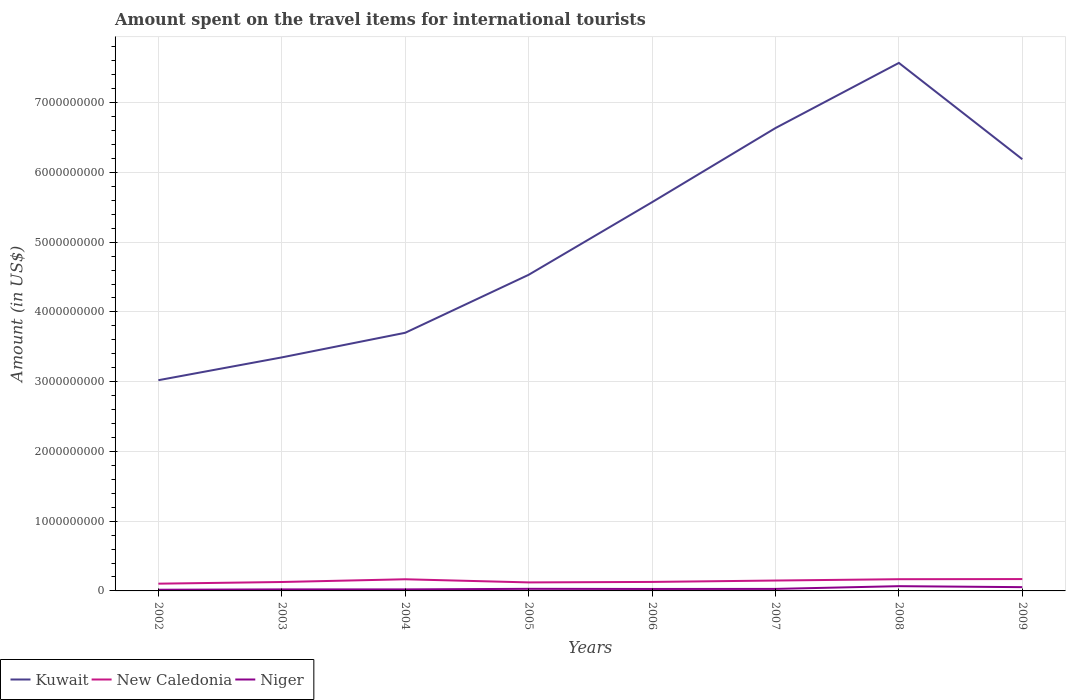How many different coloured lines are there?
Give a very brief answer. 3. Does the line corresponding to New Caledonia intersect with the line corresponding to Kuwait?
Keep it short and to the point. No. Across all years, what is the maximum amount spent on the travel items for international tourists in Niger?
Offer a terse response. 1.70e+07. What is the total amount spent on the travel items for international tourists in Kuwait in the graph?
Offer a terse response. -9.34e+08. What is the difference between the highest and the second highest amount spent on the travel items for international tourists in Niger?
Your answer should be compact. 5.10e+07. What is the difference between the highest and the lowest amount spent on the travel items for international tourists in New Caledonia?
Provide a succinct answer. 4. How many lines are there?
Provide a short and direct response. 3. Are the values on the major ticks of Y-axis written in scientific E-notation?
Provide a succinct answer. No. Does the graph contain grids?
Make the answer very short. Yes. How are the legend labels stacked?
Keep it short and to the point. Horizontal. What is the title of the graph?
Offer a terse response. Amount spent on the travel items for international tourists. Does "United Kingdom" appear as one of the legend labels in the graph?
Your response must be concise. No. What is the label or title of the Y-axis?
Ensure brevity in your answer.  Amount (in US$). What is the Amount (in US$) in Kuwait in 2002?
Offer a terse response. 3.02e+09. What is the Amount (in US$) of New Caledonia in 2002?
Offer a very short reply. 1.04e+08. What is the Amount (in US$) of Niger in 2002?
Offer a very short reply. 1.70e+07. What is the Amount (in US$) in Kuwait in 2003?
Make the answer very short. 3.35e+09. What is the Amount (in US$) of New Caledonia in 2003?
Provide a succinct answer. 1.28e+08. What is the Amount (in US$) of Niger in 2003?
Offer a very short reply. 2.20e+07. What is the Amount (in US$) in Kuwait in 2004?
Provide a succinct answer. 3.70e+09. What is the Amount (in US$) in New Caledonia in 2004?
Offer a terse response. 1.67e+08. What is the Amount (in US$) of Niger in 2004?
Make the answer very short. 2.20e+07. What is the Amount (in US$) in Kuwait in 2005?
Provide a short and direct response. 4.53e+09. What is the Amount (in US$) of New Caledonia in 2005?
Provide a succinct answer. 1.22e+08. What is the Amount (in US$) of Niger in 2005?
Offer a terse response. 3.00e+07. What is the Amount (in US$) in Kuwait in 2006?
Your answer should be compact. 5.57e+09. What is the Amount (in US$) of New Caledonia in 2006?
Provide a short and direct response. 1.29e+08. What is the Amount (in US$) in Niger in 2006?
Your answer should be very brief. 2.80e+07. What is the Amount (in US$) of Kuwait in 2007?
Your answer should be compact. 6.64e+09. What is the Amount (in US$) of New Caledonia in 2007?
Give a very brief answer. 1.49e+08. What is the Amount (in US$) in Niger in 2007?
Make the answer very short. 2.90e+07. What is the Amount (in US$) in Kuwait in 2008?
Make the answer very short. 7.57e+09. What is the Amount (in US$) in New Caledonia in 2008?
Keep it short and to the point. 1.68e+08. What is the Amount (in US$) of Niger in 2008?
Keep it short and to the point. 6.80e+07. What is the Amount (in US$) in Kuwait in 2009?
Your answer should be very brief. 6.19e+09. What is the Amount (in US$) of New Caledonia in 2009?
Your answer should be compact. 1.70e+08. What is the Amount (in US$) in Niger in 2009?
Provide a succinct answer. 5.40e+07. Across all years, what is the maximum Amount (in US$) in Kuwait?
Your answer should be compact. 7.57e+09. Across all years, what is the maximum Amount (in US$) of New Caledonia?
Provide a short and direct response. 1.70e+08. Across all years, what is the maximum Amount (in US$) in Niger?
Ensure brevity in your answer.  6.80e+07. Across all years, what is the minimum Amount (in US$) of Kuwait?
Offer a terse response. 3.02e+09. Across all years, what is the minimum Amount (in US$) in New Caledonia?
Make the answer very short. 1.04e+08. Across all years, what is the minimum Amount (in US$) of Niger?
Keep it short and to the point. 1.70e+07. What is the total Amount (in US$) of Kuwait in the graph?
Offer a very short reply. 4.06e+1. What is the total Amount (in US$) of New Caledonia in the graph?
Ensure brevity in your answer.  1.14e+09. What is the total Amount (in US$) of Niger in the graph?
Offer a very short reply. 2.70e+08. What is the difference between the Amount (in US$) in Kuwait in 2002 and that in 2003?
Your answer should be very brief. -3.27e+08. What is the difference between the Amount (in US$) in New Caledonia in 2002 and that in 2003?
Provide a short and direct response. -2.40e+07. What is the difference between the Amount (in US$) in Niger in 2002 and that in 2003?
Your answer should be very brief. -5.00e+06. What is the difference between the Amount (in US$) of Kuwait in 2002 and that in 2004?
Make the answer very short. -6.80e+08. What is the difference between the Amount (in US$) in New Caledonia in 2002 and that in 2004?
Your answer should be very brief. -6.30e+07. What is the difference between the Amount (in US$) in Niger in 2002 and that in 2004?
Offer a terse response. -5.00e+06. What is the difference between the Amount (in US$) of Kuwait in 2002 and that in 2005?
Provide a short and direct response. -1.51e+09. What is the difference between the Amount (in US$) of New Caledonia in 2002 and that in 2005?
Keep it short and to the point. -1.80e+07. What is the difference between the Amount (in US$) in Niger in 2002 and that in 2005?
Keep it short and to the point. -1.30e+07. What is the difference between the Amount (in US$) in Kuwait in 2002 and that in 2006?
Offer a very short reply. -2.55e+09. What is the difference between the Amount (in US$) in New Caledonia in 2002 and that in 2006?
Keep it short and to the point. -2.50e+07. What is the difference between the Amount (in US$) of Niger in 2002 and that in 2006?
Make the answer very short. -1.10e+07. What is the difference between the Amount (in US$) of Kuwait in 2002 and that in 2007?
Offer a terse response. -3.62e+09. What is the difference between the Amount (in US$) of New Caledonia in 2002 and that in 2007?
Your answer should be very brief. -4.50e+07. What is the difference between the Amount (in US$) in Niger in 2002 and that in 2007?
Make the answer very short. -1.20e+07. What is the difference between the Amount (in US$) of Kuwait in 2002 and that in 2008?
Provide a short and direct response. -4.55e+09. What is the difference between the Amount (in US$) of New Caledonia in 2002 and that in 2008?
Your answer should be compact. -6.40e+07. What is the difference between the Amount (in US$) in Niger in 2002 and that in 2008?
Make the answer very short. -5.10e+07. What is the difference between the Amount (in US$) in Kuwait in 2002 and that in 2009?
Provide a short and direct response. -3.17e+09. What is the difference between the Amount (in US$) of New Caledonia in 2002 and that in 2009?
Your answer should be compact. -6.60e+07. What is the difference between the Amount (in US$) of Niger in 2002 and that in 2009?
Offer a terse response. -3.70e+07. What is the difference between the Amount (in US$) of Kuwait in 2003 and that in 2004?
Your response must be concise. -3.53e+08. What is the difference between the Amount (in US$) in New Caledonia in 2003 and that in 2004?
Your answer should be very brief. -3.90e+07. What is the difference between the Amount (in US$) of Kuwait in 2003 and that in 2005?
Offer a very short reply. -1.18e+09. What is the difference between the Amount (in US$) in New Caledonia in 2003 and that in 2005?
Your answer should be compact. 6.00e+06. What is the difference between the Amount (in US$) in Niger in 2003 and that in 2005?
Your answer should be very brief. -8.00e+06. What is the difference between the Amount (in US$) in Kuwait in 2003 and that in 2006?
Your answer should be very brief. -2.22e+09. What is the difference between the Amount (in US$) of New Caledonia in 2003 and that in 2006?
Make the answer very short. -1.00e+06. What is the difference between the Amount (in US$) of Niger in 2003 and that in 2006?
Offer a terse response. -6.00e+06. What is the difference between the Amount (in US$) of Kuwait in 2003 and that in 2007?
Your answer should be compact. -3.29e+09. What is the difference between the Amount (in US$) in New Caledonia in 2003 and that in 2007?
Your answer should be very brief. -2.10e+07. What is the difference between the Amount (in US$) of Niger in 2003 and that in 2007?
Offer a very short reply. -7.00e+06. What is the difference between the Amount (in US$) in Kuwait in 2003 and that in 2008?
Ensure brevity in your answer.  -4.22e+09. What is the difference between the Amount (in US$) in New Caledonia in 2003 and that in 2008?
Ensure brevity in your answer.  -4.00e+07. What is the difference between the Amount (in US$) of Niger in 2003 and that in 2008?
Keep it short and to the point. -4.60e+07. What is the difference between the Amount (in US$) of Kuwait in 2003 and that in 2009?
Keep it short and to the point. -2.84e+09. What is the difference between the Amount (in US$) of New Caledonia in 2003 and that in 2009?
Ensure brevity in your answer.  -4.20e+07. What is the difference between the Amount (in US$) in Niger in 2003 and that in 2009?
Offer a terse response. -3.20e+07. What is the difference between the Amount (in US$) in Kuwait in 2004 and that in 2005?
Your response must be concise. -8.31e+08. What is the difference between the Amount (in US$) in New Caledonia in 2004 and that in 2005?
Offer a terse response. 4.50e+07. What is the difference between the Amount (in US$) in Niger in 2004 and that in 2005?
Give a very brief answer. -8.00e+06. What is the difference between the Amount (in US$) in Kuwait in 2004 and that in 2006?
Give a very brief answer. -1.87e+09. What is the difference between the Amount (in US$) in New Caledonia in 2004 and that in 2006?
Your response must be concise. 3.80e+07. What is the difference between the Amount (in US$) in Niger in 2004 and that in 2006?
Offer a very short reply. -6.00e+06. What is the difference between the Amount (in US$) in Kuwait in 2004 and that in 2007?
Provide a short and direct response. -2.94e+09. What is the difference between the Amount (in US$) in New Caledonia in 2004 and that in 2007?
Your response must be concise. 1.80e+07. What is the difference between the Amount (in US$) in Niger in 2004 and that in 2007?
Your answer should be very brief. -7.00e+06. What is the difference between the Amount (in US$) in Kuwait in 2004 and that in 2008?
Provide a succinct answer. -3.87e+09. What is the difference between the Amount (in US$) of New Caledonia in 2004 and that in 2008?
Ensure brevity in your answer.  -1.00e+06. What is the difference between the Amount (in US$) of Niger in 2004 and that in 2008?
Your answer should be very brief. -4.60e+07. What is the difference between the Amount (in US$) of Kuwait in 2004 and that in 2009?
Offer a very short reply. -2.49e+09. What is the difference between the Amount (in US$) in Niger in 2004 and that in 2009?
Provide a succinct answer. -3.20e+07. What is the difference between the Amount (in US$) of Kuwait in 2005 and that in 2006?
Keep it short and to the point. -1.04e+09. What is the difference between the Amount (in US$) of New Caledonia in 2005 and that in 2006?
Give a very brief answer. -7.00e+06. What is the difference between the Amount (in US$) of Niger in 2005 and that in 2006?
Keep it short and to the point. 2.00e+06. What is the difference between the Amount (in US$) in Kuwait in 2005 and that in 2007?
Your response must be concise. -2.10e+09. What is the difference between the Amount (in US$) in New Caledonia in 2005 and that in 2007?
Make the answer very short. -2.70e+07. What is the difference between the Amount (in US$) in Niger in 2005 and that in 2007?
Provide a short and direct response. 1.00e+06. What is the difference between the Amount (in US$) in Kuwait in 2005 and that in 2008?
Offer a very short reply. -3.04e+09. What is the difference between the Amount (in US$) of New Caledonia in 2005 and that in 2008?
Offer a terse response. -4.60e+07. What is the difference between the Amount (in US$) of Niger in 2005 and that in 2008?
Make the answer very short. -3.80e+07. What is the difference between the Amount (in US$) of Kuwait in 2005 and that in 2009?
Your answer should be compact. -1.66e+09. What is the difference between the Amount (in US$) in New Caledonia in 2005 and that in 2009?
Give a very brief answer. -4.80e+07. What is the difference between the Amount (in US$) of Niger in 2005 and that in 2009?
Offer a terse response. -2.40e+07. What is the difference between the Amount (in US$) in Kuwait in 2006 and that in 2007?
Offer a terse response. -1.06e+09. What is the difference between the Amount (in US$) of New Caledonia in 2006 and that in 2007?
Your response must be concise. -2.00e+07. What is the difference between the Amount (in US$) of Niger in 2006 and that in 2007?
Make the answer very short. -1.00e+06. What is the difference between the Amount (in US$) in Kuwait in 2006 and that in 2008?
Your response must be concise. -2.00e+09. What is the difference between the Amount (in US$) of New Caledonia in 2006 and that in 2008?
Your response must be concise. -3.90e+07. What is the difference between the Amount (in US$) in Niger in 2006 and that in 2008?
Give a very brief answer. -4.00e+07. What is the difference between the Amount (in US$) in Kuwait in 2006 and that in 2009?
Provide a short and direct response. -6.16e+08. What is the difference between the Amount (in US$) of New Caledonia in 2006 and that in 2009?
Your response must be concise. -4.10e+07. What is the difference between the Amount (in US$) in Niger in 2006 and that in 2009?
Provide a short and direct response. -2.60e+07. What is the difference between the Amount (in US$) of Kuwait in 2007 and that in 2008?
Make the answer very short. -9.34e+08. What is the difference between the Amount (in US$) in New Caledonia in 2007 and that in 2008?
Keep it short and to the point. -1.90e+07. What is the difference between the Amount (in US$) of Niger in 2007 and that in 2008?
Keep it short and to the point. -3.90e+07. What is the difference between the Amount (in US$) in Kuwait in 2007 and that in 2009?
Your answer should be very brief. 4.47e+08. What is the difference between the Amount (in US$) in New Caledonia in 2007 and that in 2009?
Give a very brief answer. -2.10e+07. What is the difference between the Amount (in US$) of Niger in 2007 and that in 2009?
Make the answer very short. -2.50e+07. What is the difference between the Amount (in US$) of Kuwait in 2008 and that in 2009?
Ensure brevity in your answer.  1.38e+09. What is the difference between the Amount (in US$) of New Caledonia in 2008 and that in 2009?
Your answer should be very brief. -2.00e+06. What is the difference between the Amount (in US$) of Niger in 2008 and that in 2009?
Make the answer very short. 1.40e+07. What is the difference between the Amount (in US$) in Kuwait in 2002 and the Amount (in US$) in New Caledonia in 2003?
Offer a very short reply. 2.89e+09. What is the difference between the Amount (in US$) of Kuwait in 2002 and the Amount (in US$) of Niger in 2003?
Your answer should be very brief. 3.00e+09. What is the difference between the Amount (in US$) in New Caledonia in 2002 and the Amount (in US$) in Niger in 2003?
Your answer should be very brief. 8.20e+07. What is the difference between the Amount (in US$) in Kuwait in 2002 and the Amount (in US$) in New Caledonia in 2004?
Provide a succinct answer. 2.85e+09. What is the difference between the Amount (in US$) of Kuwait in 2002 and the Amount (in US$) of Niger in 2004?
Ensure brevity in your answer.  3.00e+09. What is the difference between the Amount (in US$) of New Caledonia in 2002 and the Amount (in US$) of Niger in 2004?
Your answer should be very brief. 8.20e+07. What is the difference between the Amount (in US$) of Kuwait in 2002 and the Amount (in US$) of New Caledonia in 2005?
Provide a succinct answer. 2.90e+09. What is the difference between the Amount (in US$) of Kuwait in 2002 and the Amount (in US$) of Niger in 2005?
Give a very brief answer. 2.99e+09. What is the difference between the Amount (in US$) in New Caledonia in 2002 and the Amount (in US$) in Niger in 2005?
Keep it short and to the point. 7.40e+07. What is the difference between the Amount (in US$) in Kuwait in 2002 and the Amount (in US$) in New Caledonia in 2006?
Give a very brief answer. 2.89e+09. What is the difference between the Amount (in US$) of Kuwait in 2002 and the Amount (in US$) of Niger in 2006?
Give a very brief answer. 2.99e+09. What is the difference between the Amount (in US$) of New Caledonia in 2002 and the Amount (in US$) of Niger in 2006?
Give a very brief answer. 7.60e+07. What is the difference between the Amount (in US$) in Kuwait in 2002 and the Amount (in US$) in New Caledonia in 2007?
Ensure brevity in your answer.  2.87e+09. What is the difference between the Amount (in US$) of Kuwait in 2002 and the Amount (in US$) of Niger in 2007?
Provide a succinct answer. 2.99e+09. What is the difference between the Amount (in US$) in New Caledonia in 2002 and the Amount (in US$) in Niger in 2007?
Provide a succinct answer. 7.50e+07. What is the difference between the Amount (in US$) of Kuwait in 2002 and the Amount (in US$) of New Caledonia in 2008?
Offer a very short reply. 2.85e+09. What is the difference between the Amount (in US$) of Kuwait in 2002 and the Amount (in US$) of Niger in 2008?
Make the answer very short. 2.95e+09. What is the difference between the Amount (in US$) in New Caledonia in 2002 and the Amount (in US$) in Niger in 2008?
Offer a terse response. 3.60e+07. What is the difference between the Amount (in US$) in Kuwait in 2002 and the Amount (in US$) in New Caledonia in 2009?
Offer a terse response. 2.85e+09. What is the difference between the Amount (in US$) of Kuwait in 2002 and the Amount (in US$) of Niger in 2009?
Ensure brevity in your answer.  2.97e+09. What is the difference between the Amount (in US$) in New Caledonia in 2002 and the Amount (in US$) in Niger in 2009?
Your answer should be very brief. 5.00e+07. What is the difference between the Amount (in US$) in Kuwait in 2003 and the Amount (in US$) in New Caledonia in 2004?
Provide a short and direct response. 3.18e+09. What is the difference between the Amount (in US$) of Kuwait in 2003 and the Amount (in US$) of Niger in 2004?
Your answer should be very brief. 3.33e+09. What is the difference between the Amount (in US$) of New Caledonia in 2003 and the Amount (in US$) of Niger in 2004?
Provide a short and direct response. 1.06e+08. What is the difference between the Amount (in US$) in Kuwait in 2003 and the Amount (in US$) in New Caledonia in 2005?
Your answer should be compact. 3.23e+09. What is the difference between the Amount (in US$) in Kuwait in 2003 and the Amount (in US$) in Niger in 2005?
Offer a very short reply. 3.32e+09. What is the difference between the Amount (in US$) in New Caledonia in 2003 and the Amount (in US$) in Niger in 2005?
Give a very brief answer. 9.80e+07. What is the difference between the Amount (in US$) in Kuwait in 2003 and the Amount (in US$) in New Caledonia in 2006?
Offer a very short reply. 3.22e+09. What is the difference between the Amount (in US$) in Kuwait in 2003 and the Amount (in US$) in Niger in 2006?
Offer a very short reply. 3.32e+09. What is the difference between the Amount (in US$) of Kuwait in 2003 and the Amount (in US$) of New Caledonia in 2007?
Keep it short and to the point. 3.20e+09. What is the difference between the Amount (in US$) of Kuwait in 2003 and the Amount (in US$) of Niger in 2007?
Keep it short and to the point. 3.32e+09. What is the difference between the Amount (in US$) of New Caledonia in 2003 and the Amount (in US$) of Niger in 2007?
Keep it short and to the point. 9.90e+07. What is the difference between the Amount (in US$) of Kuwait in 2003 and the Amount (in US$) of New Caledonia in 2008?
Offer a terse response. 3.18e+09. What is the difference between the Amount (in US$) in Kuwait in 2003 and the Amount (in US$) in Niger in 2008?
Offer a very short reply. 3.28e+09. What is the difference between the Amount (in US$) in New Caledonia in 2003 and the Amount (in US$) in Niger in 2008?
Make the answer very short. 6.00e+07. What is the difference between the Amount (in US$) in Kuwait in 2003 and the Amount (in US$) in New Caledonia in 2009?
Give a very brief answer. 3.18e+09. What is the difference between the Amount (in US$) of Kuwait in 2003 and the Amount (in US$) of Niger in 2009?
Ensure brevity in your answer.  3.29e+09. What is the difference between the Amount (in US$) of New Caledonia in 2003 and the Amount (in US$) of Niger in 2009?
Give a very brief answer. 7.40e+07. What is the difference between the Amount (in US$) in Kuwait in 2004 and the Amount (in US$) in New Caledonia in 2005?
Provide a short and direct response. 3.58e+09. What is the difference between the Amount (in US$) of Kuwait in 2004 and the Amount (in US$) of Niger in 2005?
Your answer should be very brief. 3.67e+09. What is the difference between the Amount (in US$) in New Caledonia in 2004 and the Amount (in US$) in Niger in 2005?
Your answer should be compact. 1.37e+08. What is the difference between the Amount (in US$) of Kuwait in 2004 and the Amount (in US$) of New Caledonia in 2006?
Give a very brief answer. 3.57e+09. What is the difference between the Amount (in US$) of Kuwait in 2004 and the Amount (in US$) of Niger in 2006?
Offer a very short reply. 3.67e+09. What is the difference between the Amount (in US$) in New Caledonia in 2004 and the Amount (in US$) in Niger in 2006?
Your response must be concise. 1.39e+08. What is the difference between the Amount (in US$) of Kuwait in 2004 and the Amount (in US$) of New Caledonia in 2007?
Your response must be concise. 3.55e+09. What is the difference between the Amount (in US$) in Kuwait in 2004 and the Amount (in US$) in Niger in 2007?
Your answer should be very brief. 3.67e+09. What is the difference between the Amount (in US$) of New Caledonia in 2004 and the Amount (in US$) of Niger in 2007?
Offer a terse response. 1.38e+08. What is the difference between the Amount (in US$) of Kuwait in 2004 and the Amount (in US$) of New Caledonia in 2008?
Give a very brief answer. 3.53e+09. What is the difference between the Amount (in US$) of Kuwait in 2004 and the Amount (in US$) of Niger in 2008?
Offer a terse response. 3.63e+09. What is the difference between the Amount (in US$) of New Caledonia in 2004 and the Amount (in US$) of Niger in 2008?
Your answer should be compact. 9.90e+07. What is the difference between the Amount (in US$) in Kuwait in 2004 and the Amount (in US$) in New Caledonia in 2009?
Offer a very short reply. 3.53e+09. What is the difference between the Amount (in US$) of Kuwait in 2004 and the Amount (in US$) of Niger in 2009?
Your answer should be compact. 3.65e+09. What is the difference between the Amount (in US$) of New Caledonia in 2004 and the Amount (in US$) of Niger in 2009?
Provide a short and direct response. 1.13e+08. What is the difference between the Amount (in US$) in Kuwait in 2005 and the Amount (in US$) in New Caledonia in 2006?
Your answer should be compact. 4.40e+09. What is the difference between the Amount (in US$) of Kuwait in 2005 and the Amount (in US$) of Niger in 2006?
Keep it short and to the point. 4.50e+09. What is the difference between the Amount (in US$) of New Caledonia in 2005 and the Amount (in US$) of Niger in 2006?
Your response must be concise. 9.40e+07. What is the difference between the Amount (in US$) in Kuwait in 2005 and the Amount (in US$) in New Caledonia in 2007?
Your answer should be compact. 4.38e+09. What is the difference between the Amount (in US$) of Kuwait in 2005 and the Amount (in US$) of Niger in 2007?
Your response must be concise. 4.50e+09. What is the difference between the Amount (in US$) in New Caledonia in 2005 and the Amount (in US$) in Niger in 2007?
Ensure brevity in your answer.  9.30e+07. What is the difference between the Amount (in US$) of Kuwait in 2005 and the Amount (in US$) of New Caledonia in 2008?
Give a very brief answer. 4.36e+09. What is the difference between the Amount (in US$) of Kuwait in 2005 and the Amount (in US$) of Niger in 2008?
Provide a short and direct response. 4.46e+09. What is the difference between the Amount (in US$) of New Caledonia in 2005 and the Amount (in US$) of Niger in 2008?
Give a very brief answer. 5.40e+07. What is the difference between the Amount (in US$) in Kuwait in 2005 and the Amount (in US$) in New Caledonia in 2009?
Your answer should be compact. 4.36e+09. What is the difference between the Amount (in US$) of Kuwait in 2005 and the Amount (in US$) of Niger in 2009?
Provide a short and direct response. 4.48e+09. What is the difference between the Amount (in US$) of New Caledonia in 2005 and the Amount (in US$) of Niger in 2009?
Offer a terse response. 6.80e+07. What is the difference between the Amount (in US$) of Kuwait in 2006 and the Amount (in US$) of New Caledonia in 2007?
Make the answer very short. 5.42e+09. What is the difference between the Amount (in US$) of Kuwait in 2006 and the Amount (in US$) of Niger in 2007?
Your answer should be very brief. 5.54e+09. What is the difference between the Amount (in US$) of New Caledonia in 2006 and the Amount (in US$) of Niger in 2007?
Your answer should be very brief. 1.00e+08. What is the difference between the Amount (in US$) in Kuwait in 2006 and the Amount (in US$) in New Caledonia in 2008?
Your answer should be compact. 5.40e+09. What is the difference between the Amount (in US$) in Kuwait in 2006 and the Amount (in US$) in Niger in 2008?
Your answer should be compact. 5.50e+09. What is the difference between the Amount (in US$) of New Caledonia in 2006 and the Amount (in US$) of Niger in 2008?
Provide a short and direct response. 6.10e+07. What is the difference between the Amount (in US$) of Kuwait in 2006 and the Amount (in US$) of New Caledonia in 2009?
Ensure brevity in your answer.  5.40e+09. What is the difference between the Amount (in US$) in Kuwait in 2006 and the Amount (in US$) in Niger in 2009?
Offer a very short reply. 5.52e+09. What is the difference between the Amount (in US$) in New Caledonia in 2006 and the Amount (in US$) in Niger in 2009?
Make the answer very short. 7.50e+07. What is the difference between the Amount (in US$) in Kuwait in 2007 and the Amount (in US$) in New Caledonia in 2008?
Offer a terse response. 6.47e+09. What is the difference between the Amount (in US$) in Kuwait in 2007 and the Amount (in US$) in Niger in 2008?
Give a very brief answer. 6.57e+09. What is the difference between the Amount (in US$) in New Caledonia in 2007 and the Amount (in US$) in Niger in 2008?
Your answer should be very brief. 8.10e+07. What is the difference between the Amount (in US$) of Kuwait in 2007 and the Amount (in US$) of New Caledonia in 2009?
Offer a terse response. 6.47e+09. What is the difference between the Amount (in US$) of Kuwait in 2007 and the Amount (in US$) of Niger in 2009?
Provide a short and direct response. 6.58e+09. What is the difference between the Amount (in US$) of New Caledonia in 2007 and the Amount (in US$) of Niger in 2009?
Your response must be concise. 9.50e+07. What is the difference between the Amount (in US$) in Kuwait in 2008 and the Amount (in US$) in New Caledonia in 2009?
Offer a very short reply. 7.40e+09. What is the difference between the Amount (in US$) in Kuwait in 2008 and the Amount (in US$) in Niger in 2009?
Provide a short and direct response. 7.52e+09. What is the difference between the Amount (in US$) of New Caledonia in 2008 and the Amount (in US$) of Niger in 2009?
Give a very brief answer. 1.14e+08. What is the average Amount (in US$) in Kuwait per year?
Provide a succinct answer. 5.07e+09. What is the average Amount (in US$) of New Caledonia per year?
Provide a succinct answer. 1.42e+08. What is the average Amount (in US$) in Niger per year?
Offer a very short reply. 3.38e+07. In the year 2002, what is the difference between the Amount (in US$) of Kuwait and Amount (in US$) of New Caledonia?
Your answer should be compact. 2.92e+09. In the year 2002, what is the difference between the Amount (in US$) of Kuwait and Amount (in US$) of Niger?
Provide a short and direct response. 3.00e+09. In the year 2002, what is the difference between the Amount (in US$) of New Caledonia and Amount (in US$) of Niger?
Keep it short and to the point. 8.70e+07. In the year 2003, what is the difference between the Amount (in US$) of Kuwait and Amount (in US$) of New Caledonia?
Provide a short and direct response. 3.22e+09. In the year 2003, what is the difference between the Amount (in US$) of Kuwait and Amount (in US$) of Niger?
Provide a succinct answer. 3.33e+09. In the year 2003, what is the difference between the Amount (in US$) in New Caledonia and Amount (in US$) in Niger?
Give a very brief answer. 1.06e+08. In the year 2004, what is the difference between the Amount (in US$) of Kuwait and Amount (in US$) of New Caledonia?
Your response must be concise. 3.53e+09. In the year 2004, what is the difference between the Amount (in US$) of Kuwait and Amount (in US$) of Niger?
Your response must be concise. 3.68e+09. In the year 2004, what is the difference between the Amount (in US$) in New Caledonia and Amount (in US$) in Niger?
Offer a very short reply. 1.45e+08. In the year 2005, what is the difference between the Amount (in US$) in Kuwait and Amount (in US$) in New Caledonia?
Provide a succinct answer. 4.41e+09. In the year 2005, what is the difference between the Amount (in US$) in Kuwait and Amount (in US$) in Niger?
Give a very brief answer. 4.50e+09. In the year 2005, what is the difference between the Amount (in US$) in New Caledonia and Amount (in US$) in Niger?
Offer a very short reply. 9.20e+07. In the year 2006, what is the difference between the Amount (in US$) of Kuwait and Amount (in US$) of New Caledonia?
Provide a succinct answer. 5.44e+09. In the year 2006, what is the difference between the Amount (in US$) in Kuwait and Amount (in US$) in Niger?
Offer a very short reply. 5.54e+09. In the year 2006, what is the difference between the Amount (in US$) in New Caledonia and Amount (in US$) in Niger?
Keep it short and to the point. 1.01e+08. In the year 2007, what is the difference between the Amount (in US$) in Kuwait and Amount (in US$) in New Caledonia?
Your response must be concise. 6.49e+09. In the year 2007, what is the difference between the Amount (in US$) of Kuwait and Amount (in US$) of Niger?
Your response must be concise. 6.61e+09. In the year 2007, what is the difference between the Amount (in US$) in New Caledonia and Amount (in US$) in Niger?
Your response must be concise. 1.20e+08. In the year 2008, what is the difference between the Amount (in US$) in Kuwait and Amount (in US$) in New Caledonia?
Your answer should be compact. 7.40e+09. In the year 2008, what is the difference between the Amount (in US$) in Kuwait and Amount (in US$) in Niger?
Give a very brief answer. 7.50e+09. In the year 2008, what is the difference between the Amount (in US$) in New Caledonia and Amount (in US$) in Niger?
Your answer should be compact. 1.00e+08. In the year 2009, what is the difference between the Amount (in US$) in Kuwait and Amount (in US$) in New Caledonia?
Your answer should be very brief. 6.02e+09. In the year 2009, what is the difference between the Amount (in US$) of Kuwait and Amount (in US$) of Niger?
Your answer should be very brief. 6.14e+09. In the year 2009, what is the difference between the Amount (in US$) in New Caledonia and Amount (in US$) in Niger?
Provide a succinct answer. 1.16e+08. What is the ratio of the Amount (in US$) of Kuwait in 2002 to that in 2003?
Give a very brief answer. 0.9. What is the ratio of the Amount (in US$) in New Caledonia in 2002 to that in 2003?
Keep it short and to the point. 0.81. What is the ratio of the Amount (in US$) of Niger in 2002 to that in 2003?
Your answer should be very brief. 0.77. What is the ratio of the Amount (in US$) of Kuwait in 2002 to that in 2004?
Make the answer very short. 0.82. What is the ratio of the Amount (in US$) in New Caledonia in 2002 to that in 2004?
Your response must be concise. 0.62. What is the ratio of the Amount (in US$) of Niger in 2002 to that in 2004?
Your answer should be very brief. 0.77. What is the ratio of the Amount (in US$) in Kuwait in 2002 to that in 2005?
Provide a succinct answer. 0.67. What is the ratio of the Amount (in US$) in New Caledonia in 2002 to that in 2005?
Make the answer very short. 0.85. What is the ratio of the Amount (in US$) of Niger in 2002 to that in 2005?
Your response must be concise. 0.57. What is the ratio of the Amount (in US$) in Kuwait in 2002 to that in 2006?
Offer a terse response. 0.54. What is the ratio of the Amount (in US$) in New Caledonia in 2002 to that in 2006?
Ensure brevity in your answer.  0.81. What is the ratio of the Amount (in US$) in Niger in 2002 to that in 2006?
Provide a short and direct response. 0.61. What is the ratio of the Amount (in US$) in Kuwait in 2002 to that in 2007?
Ensure brevity in your answer.  0.46. What is the ratio of the Amount (in US$) of New Caledonia in 2002 to that in 2007?
Offer a very short reply. 0.7. What is the ratio of the Amount (in US$) in Niger in 2002 to that in 2007?
Provide a succinct answer. 0.59. What is the ratio of the Amount (in US$) in Kuwait in 2002 to that in 2008?
Your response must be concise. 0.4. What is the ratio of the Amount (in US$) of New Caledonia in 2002 to that in 2008?
Ensure brevity in your answer.  0.62. What is the ratio of the Amount (in US$) of Niger in 2002 to that in 2008?
Make the answer very short. 0.25. What is the ratio of the Amount (in US$) in Kuwait in 2002 to that in 2009?
Make the answer very short. 0.49. What is the ratio of the Amount (in US$) in New Caledonia in 2002 to that in 2009?
Your answer should be very brief. 0.61. What is the ratio of the Amount (in US$) in Niger in 2002 to that in 2009?
Offer a very short reply. 0.31. What is the ratio of the Amount (in US$) in Kuwait in 2003 to that in 2004?
Offer a very short reply. 0.9. What is the ratio of the Amount (in US$) in New Caledonia in 2003 to that in 2004?
Give a very brief answer. 0.77. What is the ratio of the Amount (in US$) of Niger in 2003 to that in 2004?
Provide a succinct answer. 1. What is the ratio of the Amount (in US$) of Kuwait in 2003 to that in 2005?
Give a very brief answer. 0.74. What is the ratio of the Amount (in US$) in New Caledonia in 2003 to that in 2005?
Provide a succinct answer. 1.05. What is the ratio of the Amount (in US$) of Niger in 2003 to that in 2005?
Ensure brevity in your answer.  0.73. What is the ratio of the Amount (in US$) in Kuwait in 2003 to that in 2006?
Your answer should be compact. 0.6. What is the ratio of the Amount (in US$) of Niger in 2003 to that in 2006?
Provide a succinct answer. 0.79. What is the ratio of the Amount (in US$) of Kuwait in 2003 to that in 2007?
Make the answer very short. 0.5. What is the ratio of the Amount (in US$) in New Caledonia in 2003 to that in 2007?
Keep it short and to the point. 0.86. What is the ratio of the Amount (in US$) in Niger in 2003 to that in 2007?
Keep it short and to the point. 0.76. What is the ratio of the Amount (in US$) of Kuwait in 2003 to that in 2008?
Offer a terse response. 0.44. What is the ratio of the Amount (in US$) in New Caledonia in 2003 to that in 2008?
Ensure brevity in your answer.  0.76. What is the ratio of the Amount (in US$) in Niger in 2003 to that in 2008?
Offer a terse response. 0.32. What is the ratio of the Amount (in US$) of Kuwait in 2003 to that in 2009?
Provide a short and direct response. 0.54. What is the ratio of the Amount (in US$) in New Caledonia in 2003 to that in 2009?
Offer a terse response. 0.75. What is the ratio of the Amount (in US$) of Niger in 2003 to that in 2009?
Ensure brevity in your answer.  0.41. What is the ratio of the Amount (in US$) of Kuwait in 2004 to that in 2005?
Provide a short and direct response. 0.82. What is the ratio of the Amount (in US$) of New Caledonia in 2004 to that in 2005?
Give a very brief answer. 1.37. What is the ratio of the Amount (in US$) in Niger in 2004 to that in 2005?
Provide a short and direct response. 0.73. What is the ratio of the Amount (in US$) of Kuwait in 2004 to that in 2006?
Provide a short and direct response. 0.66. What is the ratio of the Amount (in US$) of New Caledonia in 2004 to that in 2006?
Keep it short and to the point. 1.29. What is the ratio of the Amount (in US$) of Niger in 2004 to that in 2006?
Keep it short and to the point. 0.79. What is the ratio of the Amount (in US$) of Kuwait in 2004 to that in 2007?
Make the answer very short. 0.56. What is the ratio of the Amount (in US$) in New Caledonia in 2004 to that in 2007?
Provide a succinct answer. 1.12. What is the ratio of the Amount (in US$) of Niger in 2004 to that in 2007?
Keep it short and to the point. 0.76. What is the ratio of the Amount (in US$) of Kuwait in 2004 to that in 2008?
Provide a short and direct response. 0.49. What is the ratio of the Amount (in US$) of Niger in 2004 to that in 2008?
Give a very brief answer. 0.32. What is the ratio of the Amount (in US$) in Kuwait in 2004 to that in 2009?
Your answer should be very brief. 0.6. What is the ratio of the Amount (in US$) in New Caledonia in 2004 to that in 2009?
Ensure brevity in your answer.  0.98. What is the ratio of the Amount (in US$) in Niger in 2004 to that in 2009?
Offer a terse response. 0.41. What is the ratio of the Amount (in US$) of Kuwait in 2005 to that in 2006?
Your answer should be compact. 0.81. What is the ratio of the Amount (in US$) in New Caledonia in 2005 to that in 2006?
Offer a very short reply. 0.95. What is the ratio of the Amount (in US$) in Niger in 2005 to that in 2006?
Offer a terse response. 1.07. What is the ratio of the Amount (in US$) in Kuwait in 2005 to that in 2007?
Your answer should be compact. 0.68. What is the ratio of the Amount (in US$) of New Caledonia in 2005 to that in 2007?
Keep it short and to the point. 0.82. What is the ratio of the Amount (in US$) in Niger in 2005 to that in 2007?
Your answer should be compact. 1.03. What is the ratio of the Amount (in US$) of Kuwait in 2005 to that in 2008?
Your response must be concise. 0.6. What is the ratio of the Amount (in US$) of New Caledonia in 2005 to that in 2008?
Your answer should be compact. 0.73. What is the ratio of the Amount (in US$) in Niger in 2005 to that in 2008?
Offer a very short reply. 0.44. What is the ratio of the Amount (in US$) of Kuwait in 2005 to that in 2009?
Your response must be concise. 0.73. What is the ratio of the Amount (in US$) of New Caledonia in 2005 to that in 2009?
Keep it short and to the point. 0.72. What is the ratio of the Amount (in US$) of Niger in 2005 to that in 2009?
Make the answer very short. 0.56. What is the ratio of the Amount (in US$) in Kuwait in 2006 to that in 2007?
Make the answer very short. 0.84. What is the ratio of the Amount (in US$) in New Caledonia in 2006 to that in 2007?
Provide a short and direct response. 0.87. What is the ratio of the Amount (in US$) in Niger in 2006 to that in 2007?
Provide a succinct answer. 0.97. What is the ratio of the Amount (in US$) in Kuwait in 2006 to that in 2008?
Offer a terse response. 0.74. What is the ratio of the Amount (in US$) in New Caledonia in 2006 to that in 2008?
Provide a succinct answer. 0.77. What is the ratio of the Amount (in US$) of Niger in 2006 to that in 2008?
Give a very brief answer. 0.41. What is the ratio of the Amount (in US$) of Kuwait in 2006 to that in 2009?
Make the answer very short. 0.9. What is the ratio of the Amount (in US$) in New Caledonia in 2006 to that in 2009?
Offer a very short reply. 0.76. What is the ratio of the Amount (in US$) in Niger in 2006 to that in 2009?
Give a very brief answer. 0.52. What is the ratio of the Amount (in US$) in Kuwait in 2007 to that in 2008?
Offer a very short reply. 0.88. What is the ratio of the Amount (in US$) in New Caledonia in 2007 to that in 2008?
Your answer should be compact. 0.89. What is the ratio of the Amount (in US$) of Niger in 2007 to that in 2008?
Make the answer very short. 0.43. What is the ratio of the Amount (in US$) in Kuwait in 2007 to that in 2009?
Your answer should be very brief. 1.07. What is the ratio of the Amount (in US$) in New Caledonia in 2007 to that in 2009?
Make the answer very short. 0.88. What is the ratio of the Amount (in US$) of Niger in 2007 to that in 2009?
Offer a terse response. 0.54. What is the ratio of the Amount (in US$) of Kuwait in 2008 to that in 2009?
Provide a succinct answer. 1.22. What is the ratio of the Amount (in US$) of New Caledonia in 2008 to that in 2009?
Make the answer very short. 0.99. What is the ratio of the Amount (in US$) in Niger in 2008 to that in 2009?
Give a very brief answer. 1.26. What is the difference between the highest and the second highest Amount (in US$) in Kuwait?
Provide a short and direct response. 9.34e+08. What is the difference between the highest and the second highest Amount (in US$) of Niger?
Provide a short and direct response. 1.40e+07. What is the difference between the highest and the lowest Amount (in US$) of Kuwait?
Give a very brief answer. 4.55e+09. What is the difference between the highest and the lowest Amount (in US$) in New Caledonia?
Make the answer very short. 6.60e+07. What is the difference between the highest and the lowest Amount (in US$) of Niger?
Offer a very short reply. 5.10e+07. 